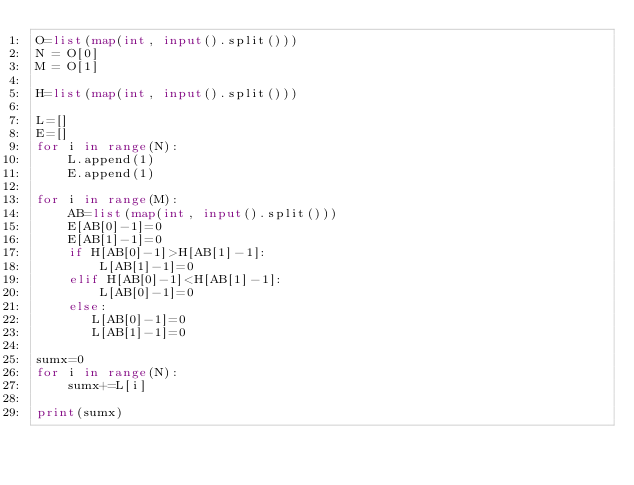Convert code to text. <code><loc_0><loc_0><loc_500><loc_500><_Python_>O=list(map(int, input().split()))
N = O[0]
M = O[1]

H=list(map(int, input().split()))

L=[]
E=[]
for i in range(N):
    L.append(1)
    E.append(1)

for i in range(M):
    AB=list(map(int, input().split()))
    E[AB[0]-1]=0
    E[AB[1]-1]=0
    if H[AB[0]-1]>H[AB[1]-1]:
        L[AB[1]-1]=0
    elif H[AB[0]-1]<H[AB[1]-1]:
        L[AB[0]-1]=0
    else:
       L[AB[0]-1]=0
       L[AB[1]-1]=0
  
sumx=0
for i in range(N):
    sumx+=L[i]

print(sumx)</code> 